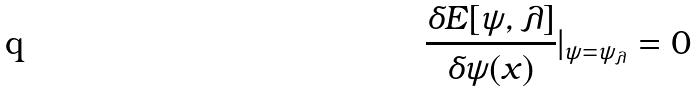Convert formula to latex. <formula><loc_0><loc_0><loc_500><loc_500>\frac { \delta E [ \psi , \lambda ] } { \delta \psi ( x ) } | _ { \psi = \psi _ { \lambda } } = 0</formula> 